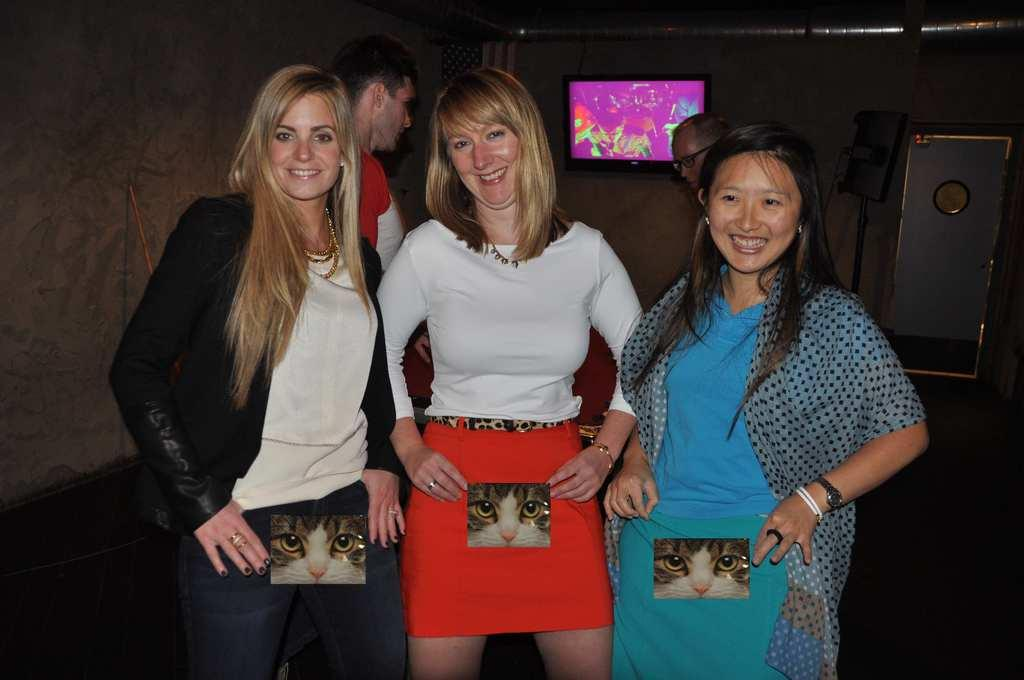How many people are present in the image? There are five people standing in the image. What is the expression of the women in the image? Three women are smiling in the image. What can be seen in the background of the image? There is a television, a door, walls, and some objects visible in the background of the image. What month is it in the image? There is no indication of the month in the image. Can you see a bed in the image? There is no bed present in the image. 